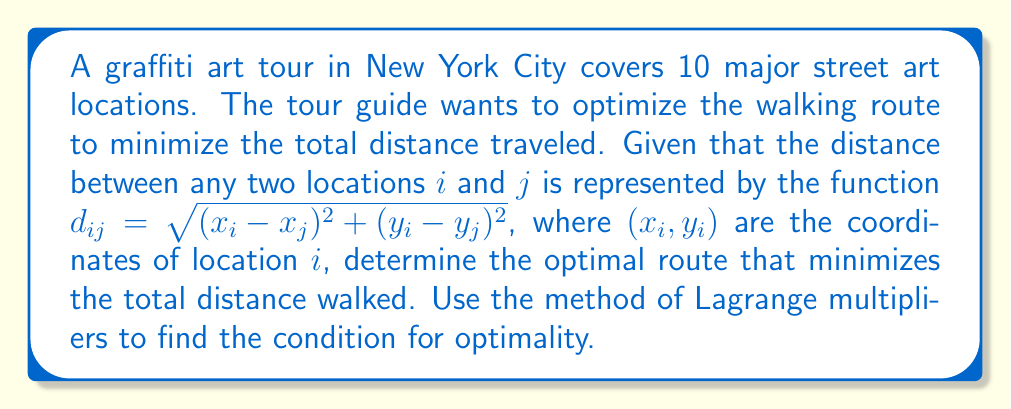Provide a solution to this math problem. To solve this optimization problem using Lagrange multipliers, we follow these steps:

1) Let's define our objective function. The total distance traveled is the sum of distances between consecutive locations:

   $$F = \sum_{i=1}^{10} d_{i,i+1} = \sum_{i=1}^{10} \sqrt{(x_i - x_{i+1})^2 + (y_i - y_{i+1})^2}$$

   where we consider location 11 to be the same as location 1 (returning to the start).

2) The constraint is that we must visit all 10 locations exactly once. This can be expressed as:

   $$G = \sum_{i=1}^{10} i - \frac{10(10+1)}{2} = 0$$

3) We form the Lagrangian:

   $$L = F + \lambda G$$

4) For optimality, we need:

   $$\frac{\partial L}{\partial x_i} = 0, \frac{\partial L}{\partial y_i} = 0, \frac{\partial L}{\partial \lambda} = 0$$

5) Focusing on the partial derivatives with respect to $x_i$ and $y_i$:

   $$\frac{\partial L}{\partial x_i} = \frac{x_i - x_{i-1}}{\sqrt{(x_i - x_{i-1})^2 + (y_i - y_{i-1})^2}} + \frac{x_i - x_{i+1}}{\sqrt{(x_i - x_{i+1})^2 + (y_i - y_{i+1})^2}} = 0$$

   $$\frac{\partial L}{\partial y_i} = \frac{y_i - y_{i-1}}{\sqrt{(x_i - x_{i-1})^2 + (y_i - y_{i-1})^2}} + \frac{y_i - y_{i+1}}{\sqrt{(x_i - x_{i+1})^2 + (y_i - y_{i+1})^2}} = 0$$

6) These equations imply that for each location $i$, the vector from $i-1$ to $i$ must be equal and opposite to the vector from $i+1$ to $i$.

This condition for optimality suggests that the optimal path forms a regular decagon, with each street art location at a vertex.
Answer: Regular decagon path 